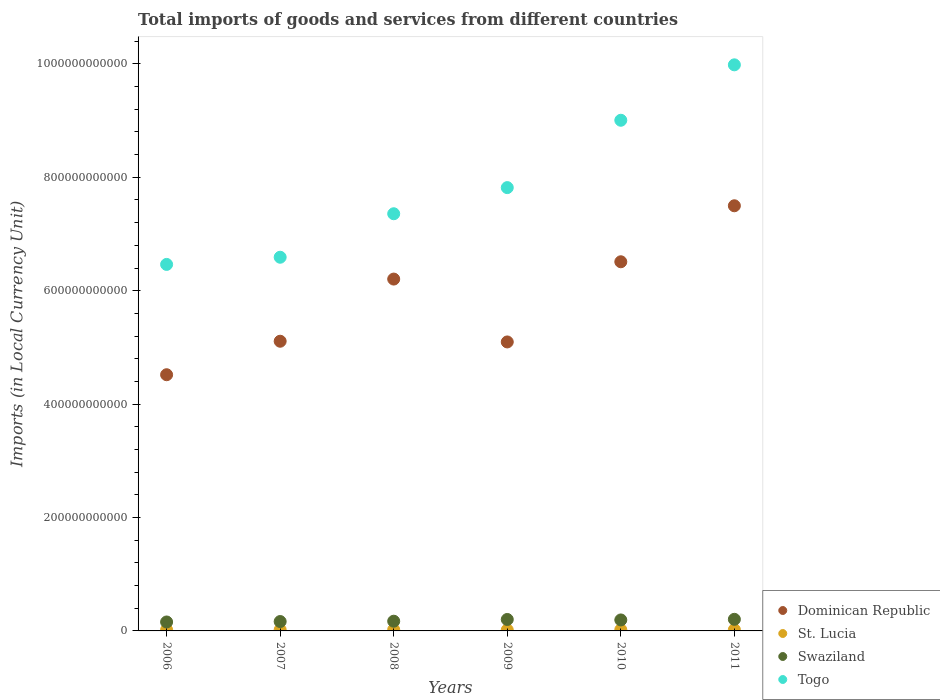What is the Amount of goods and services imports in St. Lucia in 2009?
Make the answer very short. 1.75e+09. Across all years, what is the maximum Amount of goods and services imports in St. Lucia?
Provide a succinct answer. 2.21e+09. Across all years, what is the minimum Amount of goods and services imports in Swaziland?
Make the answer very short. 1.58e+1. What is the total Amount of goods and services imports in Swaziland in the graph?
Keep it short and to the point. 1.09e+11. What is the difference between the Amount of goods and services imports in Dominican Republic in 2007 and that in 2009?
Provide a short and direct response. 1.24e+09. What is the difference between the Amount of goods and services imports in Swaziland in 2010 and the Amount of goods and services imports in St. Lucia in 2008?
Make the answer very short. 1.71e+1. What is the average Amount of goods and services imports in St. Lucia per year?
Provide a short and direct response. 2.04e+09. In the year 2010, what is the difference between the Amount of goods and services imports in Swaziland and Amount of goods and services imports in St. Lucia?
Your response must be concise. 1.72e+1. In how many years, is the Amount of goods and services imports in Swaziland greater than 880000000000 LCU?
Ensure brevity in your answer.  0. What is the ratio of the Amount of goods and services imports in St. Lucia in 2007 to that in 2011?
Your answer should be very brief. 0.92. What is the difference between the highest and the second highest Amount of goods and services imports in Togo?
Keep it short and to the point. 9.78e+1. What is the difference between the highest and the lowest Amount of goods and services imports in Dominican Republic?
Offer a terse response. 2.98e+11. Is it the case that in every year, the sum of the Amount of goods and services imports in Dominican Republic and Amount of goods and services imports in St. Lucia  is greater than the Amount of goods and services imports in Swaziland?
Your response must be concise. Yes. Does the Amount of goods and services imports in Togo monotonically increase over the years?
Your answer should be very brief. Yes. Is the Amount of goods and services imports in St. Lucia strictly greater than the Amount of goods and services imports in Swaziland over the years?
Give a very brief answer. No. Is the Amount of goods and services imports in St. Lucia strictly less than the Amount of goods and services imports in Togo over the years?
Your answer should be very brief. Yes. What is the difference between two consecutive major ticks on the Y-axis?
Keep it short and to the point. 2.00e+11. Are the values on the major ticks of Y-axis written in scientific E-notation?
Give a very brief answer. No. Does the graph contain any zero values?
Your answer should be very brief. No. How are the legend labels stacked?
Your answer should be compact. Vertical. What is the title of the graph?
Your answer should be compact. Total imports of goods and services from different countries. Does "Kuwait" appear as one of the legend labels in the graph?
Your answer should be very brief. No. What is the label or title of the Y-axis?
Your answer should be compact. Imports (in Local Currency Unit). What is the Imports (in Local Currency Unit) of Dominican Republic in 2006?
Ensure brevity in your answer.  4.52e+11. What is the Imports (in Local Currency Unit) in St. Lucia in 2006?
Offer a very short reply. 1.91e+09. What is the Imports (in Local Currency Unit) of Swaziland in 2006?
Make the answer very short. 1.58e+1. What is the Imports (in Local Currency Unit) of Togo in 2006?
Keep it short and to the point. 6.46e+11. What is the Imports (in Local Currency Unit) in Dominican Republic in 2007?
Provide a short and direct response. 5.11e+11. What is the Imports (in Local Currency Unit) in St. Lucia in 2007?
Your response must be concise. 2.02e+09. What is the Imports (in Local Currency Unit) of Swaziland in 2007?
Offer a very short reply. 1.66e+1. What is the Imports (in Local Currency Unit) of Togo in 2007?
Your response must be concise. 6.59e+11. What is the Imports (in Local Currency Unit) in Dominican Republic in 2008?
Offer a very short reply. 6.21e+11. What is the Imports (in Local Currency Unit) in St. Lucia in 2008?
Ensure brevity in your answer.  2.21e+09. What is the Imports (in Local Currency Unit) of Swaziland in 2008?
Your response must be concise. 1.71e+1. What is the Imports (in Local Currency Unit) of Togo in 2008?
Provide a short and direct response. 7.36e+11. What is the Imports (in Local Currency Unit) in Dominican Republic in 2009?
Your answer should be compact. 5.10e+11. What is the Imports (in Local Currency Unit) in St. Lucia in 2009?
Make the answer very short. 1.75e+09. What is the Imports (in Local Currency Unit) of Swaziland in 2009?
Offer a very short reply. 2.02e+1. What is the Imports (in Local Currency Unit) of Togo in 2009?
Give a very brief answer. 7.82e+11. What is the Imports (in Local Currency Unit) of Dominican Republic in 2010?
Your response must be concise. 6.51e+11. What is the Imports (in Local Currency Unit) in St. Lucia in 2010?
Give a very brief answer. 2.13e+09. What is the Imports (in Local Currency Unit) of Swaziland in 2010?
Ensure brevity in your answer.  1.94e+1. What is the Imports (in Local Currency Unit) of Togo in 2010?
Offer a terse response. 9.01e+11. What is the Imports (in Local Currency Unit) in Dominican Republic in 2011?
Offer a terse response. 7.50e+11. What is the Imports (in Local Currency Unit) of St. Lucia in 2011?
Ensure brevity in your answer.  2.20e+09. What is the Imports (in Local Currency Unit) in Swaziland in 2011?
Your response must be concise. 2.05e+1. What is the Imports (in Local Currency Unit) in Togo in 2011?
Make the answer very short. 9.98e+11. Across all years, what is the maximum Imports (in Local Currency Unit) of Dominican Republic?
Your answer should be very brief. 7.50e+11. Across all years, what is the maximum Imports (in Local Currency Unit) in St. Lucia?
Your response must be concise. 2.21e+09. Across all years, what is the maximum Imports (in Local Currency Unit) in Swaziland?
Offer a terse response. 2.05e+1. Across all years, what is the maximum Imports (in Local Currency Unit) in Togo?
Provide a succinct answer. 9.98e+11. Across all years, what is the minimum Imports (in Local Currency Unit) of Dominican Republic?
Offer a terse response. 4.52e+11. Across all years, what is the minimum Imports (in Local Currency Unit) in St. Lucia?
Provide a succinct answer. 1.75e+09. Across all years, what is the minimum Imports (in Local Currency Unit) in Swaziland?
Give a very brief answer. 1.58e+1. Across all years, what is the minimum Imports (in Local Currency Unit) in Togo?
Provide a short and direct response. 6.46e+11. What is the total Imports (in Local Currency Unit) in Dominican Republic in the graph?
Ensure brevity in your answer.  3.49e+12. What is the total Imports (in Local Currency Unit) of St. Lucia in the graph?
Offer a terse response. 1.22e+1. What is the total Imports (in Local Currency Unit) in Swaziland in the graph?
Offer a terse response. 1.09e+11. What is the total Imports (in Local Currency Unit) in Togo in the graph?
Provide a short and direct response. 4.72e+12. What is the difference between the Imports (in Local Currency Unit) of Dominican Republic in 2006 and that in 2007?
Your answer should be very brief. -5.91e+1. What is the difference between the Imports (in Local Currency Unit) in St. Lucia in 2006 and that in 2007?
Offer a very short reply. -1.10e+08. What is the difference between the Imports (in Local Currency Unit) in Swaziland in 2006 and that in 2007?
Give a very brief answer. -7.86e+08. What is the difference between the Imports (in Local Currency Unit) in Togo in 2006 and that in 2007?
Make the answer very short. -1.27e+1. What is the difference between the Imports (in Local Currency Unit) of Dominican Republic in 2006 and that in 2008?
Ensure brevity in your answer.  -1.69e+11. What is the difference between the Imports (in Local Currency Unit) of St. Lucia in 2006 and that in 2008?
Keep it short and to the point. -3.07e+08. What is the difference between the Imports (in Local Currency Unit) in Swaziland in 2006 and that in 2008?
Make the answer very short. -1.36e+09. What is the difference between the Imports (in Local Currency Unit) in Togo in 2006 and that in 2008?
Make the answer very short. -8.94e+1. What is the difference between the Imports (in Local Currency Unit) in Dominican Republic in 2006 and that in 2009?
Make the answer very short. -5.78e+1. What is the difference between the Imports (in Local Currency Unit) of St. Lucia in 2006 and that in 2009?
Make the answer very short. 1.59e+08. What is the difference between the Imports (in Local Currency Unit) of Swaziland in 2006 and that in 2009?
Keep it short and to the point. -4.43e+09. What is the difference between the Imports (in Local Currency Unit) of Togo in 2006 and that in 2009?
Provide a succinct answer. -1.35e+11. What is the difference between the Imports (in Local Currency Unit) in Dominican Republic in 2006 and that in 2010?
Ensure brevity in your answer.  -1.99e+11. What is the difference between the Imports (in Local Currency Unit) of St. Lucia in 2006 and that in 2010?
Offer a terse response. -2.18e+08. What is the difference between the Imports (in Local Currency Unit) in Swaziland in 2006 and that in 2010?
Your answer should be compact. -3.59e+09. What is the difference between the Imports (in Local Currency Unit) in Togo in 2006 and that in 2010?
Provide a succinct answer. -2.54e+11. What is the difference between the Imports (in Local Currency Unit) in Dominican Republic in 2006 and that in 2011?
Ensure brevity in your answer.  -2.98e+11. What is the difference between the Imports (in Local Currency Unit) of St. Lucia in 2006 and that in 2011?
Offer a terse response. -2.96e+08. What is the difference between the Imports (in Local Currency Unit) of Swaziland in 2006 and that in 2011?
Offer a terse response. -4.69e+09. What is the difference between the Imports (in Local Currency Unit) of Togo in 2006 and that in 2011?
Make the answer very short. -3.52e+11. What is the difference between the Imports (in Local Currency Unit) in Dominican Republic in 2007 and that in 2008?
Give a very brief answer. -1.10e+11. What is the difference between the Imports (in Local Currency Unit) in St. Lucia in 2007 and that in 2008?
Keep it short and to the point. -1.97e+08. What is the difference between the Imports (in Local Currency Unit) of Swaziland in 2007 and that in 2008?
Give a very brief answer. -5.75e+08. What is the difference between the Imports (in Local Currency Unit) in Togo in 2007 and that in 2008?
Keep it short and to the point. -7.67e+1. What is the difference between the Imports (in Local Currency Unit) in Dominican Republic in 2007 and that in 2009?
Make the answer very short. 1.24e+09. What is the difference between the Imports (in Local Currency Unit) of St. Lucia in 2007 and that in 2009?
Ensure brevity in your answer.  2.68e+08. What is the difference between the Imports (in Local Currency Unit) of Swaziland in 2007 and that in 2009?
Offer a terse response. -3.64e+09. What is the difference between the Imports (in Local Currency Unit) of Togo in 2007 and that in 2009?
Provide a succinct answer. -1.23e+11. What is the difference between the Imports (in Local Currency Unit) of Dominican Republic in 2007 and that in 2010?
Provide a succinct answer. -1.40e+11. What is the difference between the Imports (in Local Currency Unit) of St. Lucia in 2007 and that in 2010?
Keep it short and to the point. -1.08e+08. What is the difference between the Imports (in Local Currency Unit) of Swaziland in 2007 and that in 2010?
Offer a terse response. -2.80e+09. What is the difference between the Imports (in Local Currency Unit) of Togo in 2007 and that in 2010?
Your response must be concise. -2.42e+11. What is the difference between the Imports (in Local Currency Unit) in Dominican Republic in 2007 and that in 2011?
Offer a terse response. -2.39e+11. What is the difference between the Imports (in Local Currency Unit) of St. Lucia in 2007 and that in 2011?
Ensure brevity in your answer.  -1.86e+08. What is the difference between the Imports (in Local Currency Unit) in Swaziland in 2007 and that in 2011?
Provide a short and direct response. -3.90e+09. What is the difference between the Imports (in Local Currency Unit) in Togo in 2007 and that in 2011?
Your answer should be compact. -3.39e+11. What is the difference between the Imports (in Local Currency Unit) in Dominican Republic in 2008 and that in 2009?
Give a very brief answer. 1.11e+11. What is the difference between the Imports (in Local Currency Unit) of St. Lucia in 2008 and that in 2009?
Offer a very short reply. 4.65e+08. What is the difference between the Imports (in Local Currency Unit) of Swaziland in 2008 and that in 2009?
Your answer should be very brief. -3.07e+09. What is the difference between the Imports (in Local Currency Unit) in Togo in 2008 and that in 2009?
Keep it short and to the point. -4.61e+1. What is the difference between the Imports (in Local Currency Unit) in Dominican Republic in 2008 and that in 2010?
Keep it short and to the point. -3.05e+1. What is the difference between the Imports (in Local Currency Unit) of St. Lucia in 2008 and that in 2010?
Ensure brevity in your answer.  8.87e+07. What is the difference between the Imports (in Local Currency Unit) in Swaziland in 2008 and that in 2010?
Provide a short and direct response. -2.23e+09. What is the difference between the Imports (in Local Currency Unit) in Togo in 2008 and that in 2010?
Offer a very short reply. -1.65e+11. What is the difference between the Imports (in Local Currency Unit) in Dominican Republic in 2008 and that in 2011?
Your answer should be very brief. -1.29e+11. What is the difference between the Imports (in Local Currency Unit) in St. Lucia in 2008 and that in 2011?
Make the answer very short. 1.10e+07. What is the difference between the Imports (in Local Currency Unit) of Swaziland in 2008 and that in 2011?
Keep it short and to the point. -3.33e+09. What is the difference between the Imports (in Local Currency Unit) of Togo in 2008 and that in 2011?
Provide a short and direct response. -2.63e+11. What is the difference between the Imports (in Local Currency Unit) of Dominican Republic in 2009 and that in 2010?
Offer a terse response. -1.41e+11. What is the difference between the Imports (in Local Currency Unit) of St. Lucia in 2009 and that in 2010?
Provide a short and direct response. -3.77e+08. What is the difference between the Imports (in Local Currency Unit) of Swaziland in 2009 and that in 2010?
Your response must be concise. 8.39e+08. What is the difference between the Imports (in Local Currency Unit) of Togo in 2009 and that in 2010?
Your response must be concise. -1.19e+11. What is the difference between the Imports (in Local Currency Unit) in Dominican Republic in 2009 and that in 2011?
Give a very brief answer. -2.40e+11. What is the difference between the Imports (in Local Currency Unit) in St. Lucia in 2009 and that in 2011?
Your answer should be very brief. -4.54e+08. What is the difference between the Imports (in Local Currency Unit) in Swaziland in 2009 and that in 2011?
Give a very brief answer. -2.61e+08. What is the difference between the Imports (in Local Currency Unit) in Togo in 2009 and that in 2011?
Keep it short and to the point. -2.17e+11. What is the difference between the Imports (in Local Currency Unit) of Dominican Republic in 2010 and that in 2011?
Ensure brevity in your answer.  -9.88e+1. What is the difference between the Imports (in Local Currency Unit) in St. Lucia in 2010 and that in 2011?
Offer a very short reply. -7.78e+07. What is the difference between the Imports (in Local Currency Unit) of Swaziland in 2010 and that in 2011?
Provide a short and direct response. -1.10e+09. What is the difference between the Imports (in Local Currency Unit) of Togo in 2010 and that in 2011?
Keep it short and to the point. -9.78e+1. What is the difference between the Imports (in Local Currency Unit) of Dominican Republic in 2006 and the Imports (in Local Currency Unit) of St. Lucia in 2007?
Ensure brevity in your answer.  4.50e+11. What is the difference between the Imports (in Local Currency Unit) in Dominican Republic in 2006 and the Imports (in Local Currency Unit) in Swaziland in 2007?
Offer a very short reply. 4.35e+11. What is the difference between the Imports (in Local Currency Unit) of Dominican Republic in 2006 and the Imports (in Local Currency Unit) of Togo in 2007?
Your answer should be very brief. -2.07e+11. What is the difference between the Imports (in Local Currency Unit) of St. Lucia in 2006 and the Imports (in Local Currency Unit) of Swaziland in 2007?
Make the answer very short. -1.47e+1. What is the difference between the Imports (in Local Currency Unit) of St. Lucia in 2006 and the Imports (in Local Currency Unit) of Togo in 2007?
Provide a short and direct response. -6.57e+11. What is the difference between the Imports (in Local Currency Unit) of Swaziland in 2006 and the Imports (in Local Currency Unit) of Togo in 2007?
Keep it short and to the point. -6.43e+11. What is the difference between the Imports (in Local Currency Unit) of Dominican Republic in 2006 and the Imports (in Local Currency Unit) of St. Lucia in 2008?
Your response must be concise. 4.50e+11. What is the difference between the Imports (in Local Currency Unit) of Dominican Republic in 2006 and the Imports (in Local Currency Unit) of Swaziland in 2008?
Ensure brevity in your answer.  4.35e+11. What is the difference between the Imports (in Local Currency Unit) of Dominican Republic in 2006 and the Imports (in Local Currency Unit) of Togo in 2008?
Make the answer very short. -2.84e+11. What is the difference between the Imports (in Local Currency Unit) in St. Lucia in 2006 and the Imports (in Local Currency Unit) in Swaziland in 2008?
Keep it short and to the point. -1.52e+1. What is the difference between the Imports (in Local Currency Unit) in St. Lucia in 2006 and the Imports (in Local Currency Unit) in Togo in 2008?
Keep it short and to the point. -7.34e+11. What is the difference between the Imports (in Local Currency Unit) in Swaziland in 2006 and the Imports (in Local Currency Unit) in Togo in 2008?
Offer a terse response. -7.20e+11. What is the difference between the Imports (in Local Currency Unit) in Dominican Republic in 2006 and the Imports (in Local Currency Unit) in St. Lucia in 2009?
Provide a short and direct response. 4.50e+11. What is the difference between the Imports (in Local Currency Unit) in Dominican Republic in 2006 and the Imports (in Local Currency Unit) in Swaziland in 2009?
Keep it short and to the point. 4.32e+11. What is the difference between the Imports (in Local Currency Unit) in Dominican Republic in 2006 and the Imports (in Local Currency Unit) in Togo in 2009?
Offer a terse response. -3.30e+11. What is the difference between the Imports (in Local Currency Unit) in St. Lucia in 2006 and the Imports (in Local Currency Unit) in Swaziland in 2009?
Provide a succinct answer. -1.83e+1. What is the difference between the Imports (in Local Currency Unit) of St. Lucia in 2006 and the Imports (in Local Currency Unit) of Togo in 2009?
Keep it short and to the point. -7.80e+11. What is the difference between the Imports (in Local Currency Unit) in Swaziland in 2006 and the Imports (in Local Currency Unit) in Togo in 2009?
Your answer should be compact. -7.66e+11. What is the difference between the Imports (in Local Currency Unit) of Dominican Republic in 2006 and the Imports (in Local Currency Unit) of St. Lucia in 2010?
Give a very brief answer. 4.50e+11. What is the difference between the Imports (in Local Currency Unit) of Dominican Republic in 2006 and the Imports (in Local Currency Unit) of Swaziland in 2010?
Offer a terse response. 4.32e+11. What is the difference between the Imports (in Local Currency Unit) in Dominican Republic in 2006 and the Imports (in Local Currency Unit) in Togo in 2010?
Provide a succinct answer. -4.49e+11. What is the difference between the Imports (in Local Currency Unit) of St. Lucia in 2006 and the Imports (in Local Currency Unit) of Swaziland in 2010?
Offer a terse response. -1.75e+1. What is the difference between the Imports (in Local Currency Unit) of St. Lucia in 2006 and the Imports (in Local Currency Unit) of Togo in 2010?
Provide a short and direct response. -8.99e+11. What is the difference between the Imports (in Local Currency Unit) in Swaziland in 2006 and the Imports (in Local Currency Unit) in Togo in 2010?
Offer a very short reply. -8.85e+11. What is the difference between the Imports (in Local Currency Unit) of Dominican Republic in 2006 and the Imports (in Local Currency Unit) of St. Lucia in 2011?
Ensure brevity in your answer.  4.50e+11. What is the difference between the Imports (in Local Currency Unit) of Dominican Republic in 2006 and the Imports (in Local Currency Unit) of Swaziland in 2011?
Your answer should be compact. 4.31e+11. What is the difference between the Imports (in Local Currency Unit) in Dominican Republic in 2006 and the Imports (in Local Currency Unit) in Togo in 2011?
Offer a very short reply. -5.47e+11. What is the difference between the Imports (in Local Currency Unit) in St. Lucia in 2006 and the Imports (in Local Currency Unit) in Swaziland in 2011?
Your answer should be very brief. -1.86e+1. What is the difference between the Imports (in Local Currency Unit) in St. Lucia in 2006 and the Imports (in Local Currency Unit) in Togo in 2011?
Offer a very short reply. -9.96e+11. What is the difference between the Imports (in Local Currency Unit) of Swaziland in 2006 and the Imports (in Local Currency Unit) of Togo in 2011?
Offer a very short reply. -9.83e+11. What is the difference between the Imports (in Local Currency Unit) in Dominican Republic in 2007 and the Imports (in Local Currency Unit) in St. Lucia in 2008?
Provide a succinct answer. 5.09e+11. What is the difference between the Imports (in Local Currency Unit) of Dominican Republic in 2007 and the Imports (in Local Currency Unit) of Swaziland in 2008?
Make the answer very short. 4.94e+11. What is the difference between the Imports (in Local Currency Unit) in Dominican Republic in 2007 and the Imports (in Local Currency Unit) in Togo in 2008?
Offer a very short reply. -2.25e+11. What is the difference between the Imports (in Local Currency Unit) of St. Lucia in 2007 and the Imports (in Local Currency Unit) of Swaziland in 2008?
Provide a succinct answer. -1.51e+1. What is the difference between the Imports (in Local Currency Unit) of St. Lucia in 2007 and the Imports (in Local Currency Unit) of Togo in 2008?
Provide a short and direct response. -7.34e+11. What is the difference between the Imports (in Local Currency Unit) in Swaziland in 2007 and the Imports (in Local Currency Unit) in Togo in 2008?
Offer a terse response. -7.19e+11. What is the difference between the Imports (in Local Currency Unit) in Dominican Republic in 2007 and the Imports (in Local Currency Unit) in St. Lucia in 2009?
Give a very brief answer. 5.09e+11. What is the difference between the Imports (in Local Currency Unit) of Dominican Republic in 2007 and the Imports (in Local Currency Unit) of Swaziland in 2009?
Your response must be concise. 4.91e+11. What is the difference between the Imports (in Local Currency Unit) of Dominican Republic in 2007 and the Imports (in Local Currency Unit) of Togo in 2009?
Your answer should be compact. -2.71e+11. What is the difference between the Imports (in Local Currency Unit) of St. Lucia in 2007 and the Imports (in Local Currency Unit) of Swaziland in 2009?
Keep it short and to the point. -1.82e+1. What is the difference between the Imports (in Local Currency Unit) of St. Lucia in 2007 and the Imports (in Local Currency Unit) of Togo in 2009?
Keep it short and to the point. -7.80e+11. What is the difference between the Imports (in Local Currency Unit) in Swaziland in 2007 and the Imports (in Local Currency Unit) in Togo in 2009?
Provide a short and direct response. -7.65e+11. What is the difference between the Imports (in Local Currency Unit) of Dominican Republic in 2007 and the Imports (in Local Currency Unit) of St. Lucia in 2010?
Make the answer very short. 5.09e+11. What is the difference between the Imports (in Local Currency Unit) of Dominican Republic in 2007 and the Imports (in Local Currency Unit) of Swaziland in 2010?
Provide a short and direct response. 4.92e+11. What is the difference between the Imports (in Local Currency Unit) in Dominican Republic in 2007 and the Imports (in Local Currency Unit) in Togo in 2010?
Offer a very short reply. -3.90e+11. What is the difference between the Imports (in Local Currency Unit) in St. Lucia in 2007 and the Imports (in Local Currency Unit) in Swaziland in 2010?
Keep it short and to the point. -1.73e+1. What is the difference between the Imports (in Local Currency Unit) in St. Lucia in 2007 and the Imports (in Local Currency Unit) in Togo in 2010?
Your response must be concise. -8.99e+11. What is the difference between the Imports (in Local Currency Unit) of Swaziland in 2007 and the Imports (in Local Currency Unit) of Togo in 2010?
Your answer should be very brief. -8.84e+11. What is the difference between the Imports (in Local Currency Unit) in Dominican Republic in 2007 and the Imports (in Local Currency Unit) in St. Lucia in 2011?
Make the answer very short. 5.09e+11. What is the difference between the Imports (in Local Currency Unit) of Dominican Republic in 2007 and the Imports (in Local Currency Unit) of Swaziland in 2011?
Offer a very short reply. 4.90e+11. What is the difference between the Imports (in Local Currency Unit) in Dominican Republic in 2007 and the Imports (in Local Currency Unit) in Togo in 2011?
Offer a very short reply. -4.87e+11. What is the difference between the Imports (in Local Currency Unit) in St. Lucia in 2007 and the Imports (in Local Currency Unit) in Swaziland in 2011?
Your response must be concise. -1.84e+1. What is the difference between the Imports (in Local Currency Unit) in St. Lucia in 2007 and the Imports (in Local Currency Unit) in Togo in 2011?
Offer a very short reply. -9.96e+11. What is the difference between the Imports (in Local Currency Unit) of Swaziland in 2007 and the Imports (in Local Currency Unit) of Togo in 2011?
Offer a very short reply. -9.82e+11. What is the difference between the Imports (in Local Currency Unit) in Dominican Republic in 2008 and the Imports (in Local Currency Unit) in St. Lucia in 2009?
Offer a very short reply. 6.19e+11. What is the difference between the Imports (in Local Currency Unit) in Dominican Republic in 2008 and the Imports (in Local Currency Unit) in Swaziland in 2009?
Offer a terse response. 6.00e+11. What is the difference between the Imports (in Local Currency Unit) of Dominican Republic in 2008 and the Imports (in Local Currency Unit) of Togo in 2009?
Provide a short and direct response. -1.61e+11. What is the difference between the Imports (in Local Currency Unit) of St. Lucia in 2008 and the Imports (in Local Currency Unit) of Swaziland in 2009?
Your response must be concise. -1.80e+1. What is the difference between the Imports (in Local Currency Unit) in St. Lucia in 2008 and the Imports (in Local Currency Unit) in Togo in 2009?
Provide a succinct answer. -7.80e+11. What is the difference between the Imports (in Local Currency Unit) of Swaziland in 2008 and the Imports (in Local Currency Unit) of Togo in 2009?
Keep it short and to the point. -7.65e+11. What is the difference between the Imports (in Local Currency Unit) in Dominican Republic in 2008 and the Imports (in Local Currency Unit) in St. Lucia in 2010?
Your response must be concise. 6.18e+11. What is the difference between the Imports (in Local Currency Unit) of Dominican Republic in 2008 and the Imports (in Local Currency Unit) of Swaziland in 2010?
Your response must be concise. 6.01e+11. What is the difference between the Imports (in Local Currency Unit) of Dominican Republic in 2008 and the Imports (in Local Currency Unit) of Togo in 2010?
Your response must be concise. -2.80e+11. What is the difference between the Imports (in Local Currency Unit) of St. Lucia in 2008 and the Imports (in Local Currency Unit) of Swaziland in 2010?
Keep it short and to the point. -1.71e+1. What is the difference between the Imports (in Local Currency Unit) in St. Lucia in 2008 and the Imports (in Local Currency Unit) in Togo in 2010?
Your answer should be very brief. -8.98e+11. What is the difference between the Imports (in Local Currency Unit) in Swaziland in 2008 and the Imports (in Local Currency Unit) in Togo in 2010?
Provide a short and direct response. -8.83e+11. What is the difference between the Imports (in Local Currency Unit) of Dominican Republic in 2008 and the Imports (in Local Currency Unit) of St. Lucia in 2011?
Your answer should be very brief. 6.18e+11. What is the difference between the Imports (in Local Currency Unit) of Dominican Republic in 2008 and the Imports (in Local Currency Unit) of Swaziland in 2011?
Your answer should be very brief. 6.00e+11. What is the difference between the Imports (in Local Currency Unit) of Dominican Republic in 2008 and the Imports (in Local Currency Unit) of Togo in 2011?
Make the answer very short. -3.78e+11. What is the difference between the Imports (in Local Currency Unit) in St. Lucia in 2008 and the Imports (in Local Currency Unit) in Swaziland in 2011?
Provide a succinct answer. -1.82e+1. What is the difference between the Imports (in Local Currency Unit) of St. Lucia in 2008 and the Imports (in Local Currency Unit) of Togo in 2011?
Your answer should be compact. -9.96e+11. What is the difference between the Imports (in Local Currency Unit) of Swaziland in 2008 and the Imports (in Local Currency Unit) of Togo in 2011?
Give a very brief answer. -9.81e+11. What is the difference between the Imports (in Local Currency Unit) in Dominican Republic in 2009 and the Imports (in Local Currency Unit) in St. Lucia in 2010?
Provide a short and direct response. 5.08e+11. What is the difference between the Imports (in Local Currency Unit) in Dominican Republic in 2009 and the Imports (in Local Currency Unit) in Swaziland in 2010?
Your response must be concise. 4.90e+11. What is the difference between the Imports (in Local Currency Unit) of Dominican Republic in 2009 and the Imports (in Local Currency Unit) of Togo in 2010?
Your response must be concise. -3.91e+11. What is the difference between the Imports (in Local Currency Unit) of St. Lucia in 2009 and the Imports (in Local Currency Unit) of Swaziland in 2010?
Provide a succinct answer. -1.76e+1. What is the difference between the Imports (in Local Currency Unit) of St. Lucia in 2009 and the Imports (in Local Currency Unit) of Togo in 2010?
Offer a terse response. -8.99e+11. What is the difference between the Imports (in Local Currency Unit) in Swaziland in 2009 and the Imports (in Local Currency Unit) in Togo in 2010?
Keep it short and to the point. -8.80e+11. What is the difference between the Imports (in Local Currency Unit) of Dominican Republic in 2009 and the Imports (in Local Currency Unit) of St. Lucia in 2011?
Keep it short and to the point. 5.07e+11. What is the difference between the Imports (in Local Currency Unit) of Dominican Republic in 2009 and the Imports (in Local Currency Unit) of Swaziland in 2011?
Offer a terse response. 4.89e+11. What is the difference between the Imports (in Local Currency Unit) of Dominican Republic in 2009 and the Imports (in Local Currency Unit) of Togo in 2011?
Offer a terse response. -4.89e+11. What is the difference between the Imports (in Local Currency Unit) in St. Lucia in 2009 and the Imports (in Local Currency Unit) in Swaziland in 2011?
Make the answer very short. -1.87e+1. What is the difference between the Imports (in Local Currency Unit) of St. Lucia in 2009 and the Imports (in Local Currency Unit) of Togo in 2011?
Your response must be concise. -9.97e+11. What is the difference between the Imports (in Local Currency Unit) of Swaziland in 2009 and the Imports (in Local Currency Unit) of Togo in 2011?
Your response must be concise. -9.78e+11. What is the difference between the Imports (in Local Currency Unit) in Dominican Republic in 2010 and the Imports (in Local Currency Unit) in St. Lucia in 2011?
Provide a succinct answer. 6.49e+11. What is the difference between the Imports (in Local Currency Unit) in Dominican Republic in 2010 and the Imports (in Local Currency Unit) in Swaziland in 2011?
Make the answer very short. 6.31e+11. What is the difference between the Imports (in Local Currency Unit) of Dominican Republic in 2010 and the Imports (in Local Currency Unit) of Togo in 2011?
Ensure brevity in your answer.  -3.47e+11. What is the difference between the Imports (in Local Currency Unit) in St. Lucia in 2010 and the Imports (in Local Currency Unit) in Swaziland in 2011?
Ensure brevity in your answer.  -1.83e+1. What is the difference between the Imports (in Local Currency Unit) of St. Lucia in 2010 and the Imports (in Local Currency Unit) of Togo in 2011?
Offer a terse response. -9.96e+11. What is the difference between the Imports (in Local Currency Unit) in Swaziland in 2010 and the Imports (in Local Currency Unit) in Togo in 2011?
Your answer should be compact. -9.79e+11. What is the average Imports (in Local Currency Unit) of Dominican Republic per year?
Ensure brevity in your answer.  5.82e+11. What is the average Imports (in Local Currency Unit) in St. Lucia per year?
Your answer should be very brief. 2.04e+09. What is the average Imports (in Local Currency Unit) of Swaziland per year?
Your answer should be compact. 1.82e+1. What is the average Imports (in Local Currency Unit) in Togo per year?
Offer a very short reply. 7.87e+11. In the year 2006, what is the difference between the Imports (in Local Currency Unit) in Dominican Republic and Imports (in Local Currency Unit) in St. Lucia?
Your response must be concise. 4.50e+11. In the year 2006, what is the difference between the Imports (in Local Currency Unit) in Dominican Republic and Imports (in Local Currency Unit) in Swaziland?
Provide a short and direct response. 4.36e+11. In the year 2006, what is the difference between the Imports (in Local Currency Unit) of Dominican Republic and Imports (in Local Currency Unit) of Togo?
Make the answer very short. -1.95e+11. In the year 2006, what is the difference between the Imports (in Local Currency Unit) in St. Lucia and Imports (in Local Currency Unit) in Swaziland?
Offer a very short reply. -1.39e+1. In the year 2006, what is the difference between the Imports (in Local Currency Unit) in St. Lucia and Imports (in Local Currency Unit) in Togo?
Offer a terse response. -6.44e+11. In the year 2006, what is the difference between the Imports (in Local Currency Unit) of Swaziland and Imports (in Local Currency Unit) of Togo?
Give a very brief answer. -6.31e+11. In the year 2007, what is the difference between the Imports (in Local Currency Unit) of Dominican Republic and Imports (in Local Currency Unit) of St. Lucia?
Provide a succinct answer. 5.09e+11. In the year 2007, what is the difference between the Imports (in Local Currency Unit) in Dominican Republic and Imports (in Local Currency Unit) in Swaziland?
Make the answer very short. 4.94e+11. In the year 2007, what is the difference between the Imports (in Local Currency Unit) of Dominican Republic and Imports (in Local Currency Unit) of Togo?
Ensure brevity in your answer.  -1.48e+11. In the year 2007, what is the difference between the Imports (in Local Currency Unit) of St. Lucia and Imports (in Local Currency Unit) of Swaziland?
Your answer should be very brief. -1.45e+1. In the year 2007, what is the difference between the Imports (in Local Currency Unit) of St. Lucia and Imports (in Local Currency Unit) of Togo?
Provide a short and direct response. -6.57e+11. In the year 2007, what is the difference between the Imports (in Local Currency Unit) in Swaziland and Imports (in Local Currency Unit) in Togo?
Your response must be concise. -6.42e+11. In the year 2008, what is the difference between the Imports (in Local Currency Unit) in Dominican Republic and Imports (in Local Currency Unit) in St. Lucia?
Ensure brevity in your answer.  6.18e+11. In the year 2008, what is the difference between the Imports (in Local Currency Unit) of Dominican Republic and Imports (in Local Currency Unit) of Swaziland?
Offer a very short reply. 6.03e+11. In the year 2008, what is the difference between the Imports (in Local Currency Unit) of Dominican Republic and Imports (in Local Currency Unit) of Togo?
Provide a short and direct response. -1.15e+11. In the year 2008, what is the difference between the Imports (in Local Currency Unit) of St. Lucia and Imports (in Local Currency Unit) of Swaziland?
Provide a succinct answer. -1.49e+1. In the year 2008, what is the difference between the Imports (in Local Currency Unit) of St. Lucia and Imports (in Local Currency Unit) of Togo?
Make the answer very short. -7.34e+11. In the year 2008, what is the difference between the Imports (in Local Currency Unit) of Swaziland and Imports (in Local Currency Unit) of Togo?
Offer a very short reply. -7.19e+11. In the year 2009, what is the difference between the Imports (in Local Currency Unit) in Dominican Republic and Imports (in Local Currency Unit) in St. Lucia?
Give a very brief answer. 5.08e+11. In the year 2009, what is the difference between the Imports (in Local Currency Unit) of Dominican Republic and Imports (in Local Currency Unit) of Swaziland?
Provide a short and direct response. 4.89e+11. In the year 2009, what is the difference between the Imports (in Local Currency Unit) in Dominican Republic and Imports (in Local Currency Unit) in Togo?
Provide a short and direct response. -2.72e+11. In the year 2009, what is the difference between the Imports (in Local Currency Unit) of St. Lucia and Imports (in Local Currency Unit) of Swaziland?
Offer a terse response. -1.85e+1. In the year 2009, what is the difference between the Imports (in Local Currency Unit) of St. Lucia and Imports (in Local Currency Unit) of Togo?
Offer a terse response. -7.80e+11. In the year 2009, what is the difference between the Imports (in Local Currency Unit) of Swaziland and Imports (in Local Currency Unit) of Togo?
Offer a terse response. -7.62e+11. In the year 2010, what is the difference between the Imports (in Local Currency Unit) of Dominican Republic and Imports (in Local Currency Unit) of St. Lucia?
Keep it short and to the point. 6.49e+11. In the year 2010, what is the difference between the Imports (in Local Currency Unit) in Dominican Republic and Imports (in Local Currency Unit) in Swaziland?
Make the answer very short. 6.32e+11. In the year 2010, what is the difference between the Imports (in Local Currency Unit) in Dominican Republic and Imports (in Local Currency Unit) in Togo?
Provide a succinct answer. -2.50e+11. In the year 2010, what is the difference between the Imports (in Local Currency Unit) in St. Lucia and Imports (in Local Currency Unit) in Swaziland?
Ensure brevity in your answer.  -1.72e+1. In the year 2010, what is the difference between the Imports (in Local Currency Unit) in St. Lucia and Imports (in Local Currency Unit) in Togo?
Offer a terse response. -8.98e+11. In the year 2010, what is the difference between the Imports (in Local Currency Unit) of Swaziland and Imports (in Local Currency Unit) of Togo?
Keep it short and to the point. -8.81e+11. In the year 2011, what is the difference between the Imports (in Local Currency Unit) of Dominican Republic and Imports (in Local Currency Unit) of St. Lucia?
Provide a succinct answer. 7.48e+11. In the year 2011, what is the difference between the Imports (in Local Currency Unit) of Dominican Republic and Imports (in Local Currency Unit) of Swaziland?
Give a very brief answer. 7.29e+11. In the year 2011, what is the difference between the Imports (in Local Currency Unit) of Dominican Republic and Imports (in Local Currency Unit) of Togo?
Give a very brief answer. -2.49e+11. In the year 2011, what is the difference between the Imports (in Local Currency Unit) in St. Lucia and Imports (in Local Currency Unit) in Swaziland?
Ensure brevity in your answer.  -1.83e+1. In the year 2011, what is the difference between the Imports (in Local Currency Unit) of St. Lucia and Imports (in Local Currency Unit) of Togo?
Provide a succinct answer. -9.96e+11. In the year 2011, what is the difference between the Imports (in Local Currency Unit) of Swaziland and Imports (in Local Currency Unit) of Togo?
Give a very brief answer. -9.78e+11. What is the ratio of the Imports (in Local Currency Unit) of Dominican Republic in 2006 to that in 2007?
Give a very brief answer. 0.88. What is the ratio of the Imports (in Local Currency Unit) of St. Lucia in 2006 to that in 2007?
Ensure brevity in your answer.  0.95. What is the ratio of the Imports (in Local Currency Unit) in Swaziland in 2006 to that in 2007?
Ensure brevity in your answer.  0.95. What is the ratio of the Imports (in Local Currency Unit) in Togo in 2006 to that in 2007?
Your response must be concise. 0.98. What is the ratio of the Imports (in Local Currency Unit) of Dominican Republic in 2006 to that in 2008?
Provide a succinct answer. 0.73. What is the ratio of the Imports (in Local Currency Unit) in St. Lucia in 2006 to that in 2008?
Keep it short and to the point. 0.86. What is the ratio of the Imports (in Local Currency Unit) of Swaziland in 2006 to that in 2008?
Make the answer very short. 0.92. What is the ratio of the Imports (in Local Currency Unit) of Togo in 2006 to that in 2008?
Your answer should be compact. 0.88. What is the ratio of the Imports (in Local Currency Unit) in Dominican Republic in 2006 to that in 2009?
Provide a succinct answer. 0.89. What is the ratio of the Imports (in Local Currency Unit) of St. Lucia in 2006 to that in 2009?
Ensure brevity in your answer.  1.09. What is the ratio of the Imports (in Local Currency Unit) of Swaziland in 2006 to that in 2009?
Provide a short and direct response. 0.78. What is the ratio of the Imports (in Local Currency Unit) of Togo in 2006 to that in 2009?
Provide a short and direct response. 0.83. What is the ratio of the Imports (in Local Currency Unit) of Dominican Republic in 2006 to that in 2010?
Offer a very short reply. 0.69. What is the ratio of the Imports (in Local Currency Unit) in St. Lucia in 2006 to that in 2010?
Your answer should be very brief. 0.9. What is the ratio of the Imports (in Local Currency Unit) of Swaziland in 2006 to that in 2010?
Make the answer very short. 0.81. What is the ratio of the Imports (in Local Currency Unit) of Togo in 2006 to that in 2010?
Provide a succinct answer. 0.72. What is the ratio of the Imports (in Local Currency Unit) in Dominican Republic in 2006 to that in 2011?
Give a very brief answer. 0.6. What is the ratio of the Imports (in Local Currency Unit) in St. Lucia in 2006 to that in 2011?
Offer a very short reply. 0.87. What is the ratio of the Imports (in Local Currency Unit) in Swaziland in 2006 to that in 2011?
Offer a terse response. 0.77. What is the ratio of the Imports (in Local Currency Unit) of Togo in 2006 to that in 2011?
Make the answer very short. 0.65. What is the ratio of the Imports (in Local Currency Unit) in Dominican Republic in 2007 to that in 2008?
Your answer should be very brief. 0.82. What is the ratio of the Imports (in Local Currency Unit) in St. Lucia in 2007 to that in 2008?
Your answer should be compact. 0.91. What is the ratio of the Imports (in Local Currency Unit) of Swaziland in 2007 to that in 2008?
Provide a short and direct response. 0.97. What is the ratio of the Imports (in Local Currency Unit) of Togo in 2007 to that in 2008?
Provide a short and direct response. 0.9. What is the ratio of the Imports (in Local Currency Unit) of St. Lucia in 2007 to that in 2009?
Keep it short and to the point. 1.15. What is the ratio of the Imports (in Local Currency Unit) in Swaziland in 2007 to that in 2009?
Offer a terse response. 0.82. What is the ratio of the Imports (in Local Currency Unit) in Togo in 2007 to that in 2009?
Provide a succinct answer. 0.84. What is the ratio of the Imports (in Local Currency Unit) of Dominican Republic in 2007 to that in 2010?
Offer a terse response. 0.78. What is the ratio of the Imports (in Local Currency Unit) in St. Lucia in 2007 to that in 2010?
Make the answer very short. 0.95. What is the ratio of the Imports (in Local Currency Unit) of Swaziland in 2007 to that in 2010?
Your answer should be compact. 0.86. What is the ratio of the Imports (in Local Currency Unit) in Togo in 2007 to that in 2010?
Offer a very short reply. 0.73. What is the ratio of the Imports (in Local Currency Unit) in Dominican Republic in 2007 to that in 2011?
Provide a succinct answer. 0.68. What is the ratio of the Imports (in Local Currency Unit) of St. Lucia in 2007 to that in 2011?
Ensure brevity in your answer.  0.92. What is the ratio of the Imports (in Local Currency Unit) of Swaziland in 2007 to that in 2011?
Make the answer very short. 0.81. What is the ratio of the Imports (in Local Currency Unit) of Togo in 2007 to that in 2011?
Keep it short and to the point. 0.66. What is the ratio of the Imports (in Local Currency Unit) of Dominican Republic in 2008 to that in 2009?
Your answer should be compact. 1.22. What is the ratio of the Imports (in Local Currency Unit) in St. Lucia in 2008 to that in 2009?
Ensure brevity in your answer.  1.27. What is the ratio of the Imports (in Local Currency Unit) in Swaziland in 2008 to that in 2009?
Your answer should be compact. 0.85. What is the ratio of the Imports (in Local Currency Unit) of Togo in 2008 to that in 2009?
Keep it short and to the point. 0.94. What is the ratio of the Imports (in Local Currency Unit) in Dominican Republic in 2008 to that in 2010?
Make the answer very short. 0.95. What is the ratio of the Imports (in Local Currency Unit) in St. Lucia in 2008 to that in 2010?
Your response must be concise. 1.04. What is the ratio of the Imports (in Local Currency Unit) of Swaziland in 2008 to that in 2010?
Your answer should be very brief. 0.88. What is the ratio of the Imports (in Local Currency Unit) in Togo in 2008 to that in 2010?
Provide a short and direct response. 0.82. What is the ratio of the Imports (in Local Currency Unit) in Dominican Republic in 2008 to that in 2011?
Your response must be concise. 0.83. What is the ratio of the Imports (in Local Currency Unit) in St. Lucia in 2008 to that in 2011?
Provide a short and direct response. 1. What is the ratio of the Imports (in Local Currency Unit) of Swaziland in 2008 to that in 2011?
Your response must be concise. 0.84. What is the ratio of the Imports (in Local Currency Unit) of Togo in 2008 to that in 2011?
Offer a very short reply. 0.74. What is the ratio of the Imports (in Local Currency Unit) of Dominican Republic in 2009 to that in 2010?
Provide a succinct answer. 0.78. What is the ratio of the Imports (in Local Currency Unit) in St. Lucia in 2009 to that in 2010?
Ensure brevity in your answer.  0.82. What is the ratio of the Imports (in Local Currency Unit) in Swaziland in 2009 to that in 2010?
Your response must be concise. 1.04. What is the ratio of the Imports (in Local Currency Unit) of Togo in 2009 to that in 2010?
Your response must be concise. 0.87. What is the ratio of the Imports (in Local Currency Unit) in Dominican Republic in 2009 to that in 2011?
Your answer should be very brief. 0.68. What is the ratio of the Imports (in Local Currency Unit) in St. Lucia in 2009 to that in 2011?
Offer a very short reply. 0.79. What is the ratio of the Imports (in Local Currency Unit) of Swaziland in 2009 to that in 2011?
Provide a succinct answer. 0.99. What is the ratio of the Imports (in Local Currency Unit) in Togo in 2009 to that in 2011?
Ensure brevity in your answer.  0.78. What is the ratio of the Imports (in Local Currency Unit) in Dominican Republic in 2010 to that in 2011?
Provide a short and direct response. 0.87. What is the ratio of the Imports (in Local Currency Unit) in St. Lucia in 2010 to that in 2011?
Ensure brevity in your answer.  0.96. What is the ratio of the Imports (in Local Currency Unit) of Swaziland in 2010 to that in 2011?
Give a very brief answer. 0.95. What is the ratio of the Imports (in Local Currency Unit) of Togo in 2010 to that in 2011?
Give a very brief answer. 0.9. What is the difference between the highest and the second highest Imports (in Local Currency Unit) of Dominican Republic?
Give a very brief answer. 9.88e+1. What is the difference between the highest and the second highest Imports (in Local Currency Unit) in St. Lucia?
Your answer should be very brief. 1.10e+07. What is the difference between the highest and the second highest Imports (in Local Currency Unit) in Swaziland?
Ensure brevity in your answer.  2.61e+08. What is the difference between the highest and the second highest Imports (in Local Currency Unit) of Togo?
Give a very brief answer. 9.78e+1. What is the difference between the highest and the lowest Imports (in Local Currency Unit) of Dominican Republic?
Your answer should be very brief. 2.98e+11. What is the difference between the highest and the lowest Imports (in Local Currency Unit) of St. Lucia?
Make the answer very short. 4.65e+08. What is the difference between the highest and the lowest Imports (in Local Currency Unit) in Swaziland?
Your response must be concise. 4.69e+09. What is the difference between the highest and the lowest Imports (in Local Currency Unit) of Togo?
Your response must be concise. 3.52e+11. 